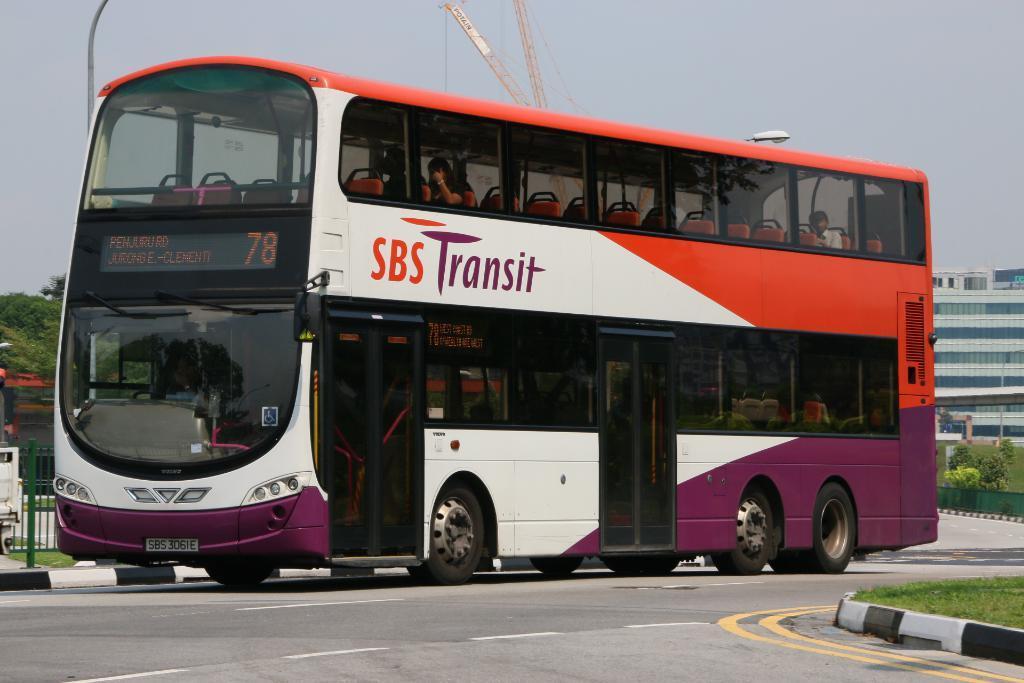How would you summarize this image in a sentence or two? In this image in the center there is a bus with some text and numbers written on it is moving on the road with the persons sitting in it. In the front on the right side there's grass on the ground. In the background there are trees, buildings, there is a fence and the sky is cloudy. 